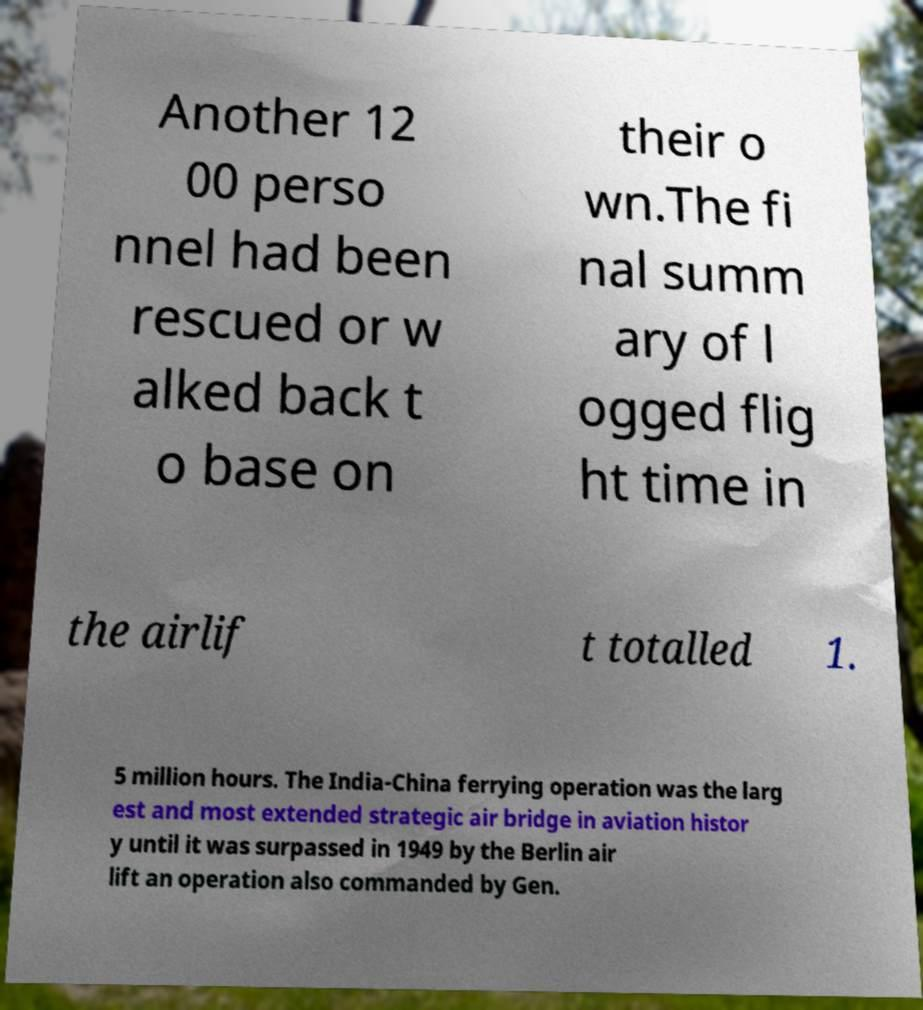Please identify and transcribe the text found in this image. Another 12 00 perso nnel had been rescued or w alked back t o base on their o wn.The fi nal summ ary of l ogged flig ht time in the airlif t totalled 1. 5 million hours. The India-China ferrying operation was the larg est and most extended strategic air bridge in aviation histor y until it was surpassed in 1949 by the Berlin air lift an operation also commanded by Gen. 